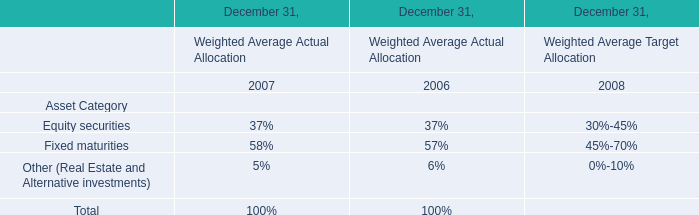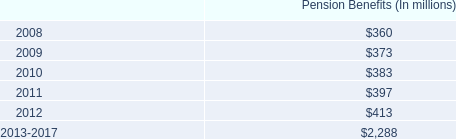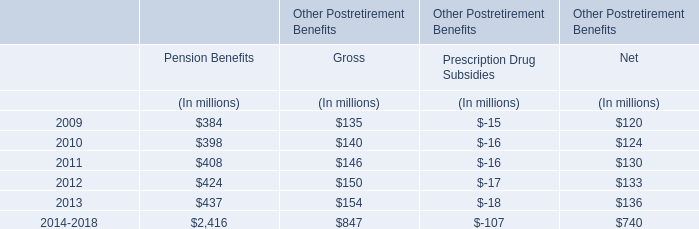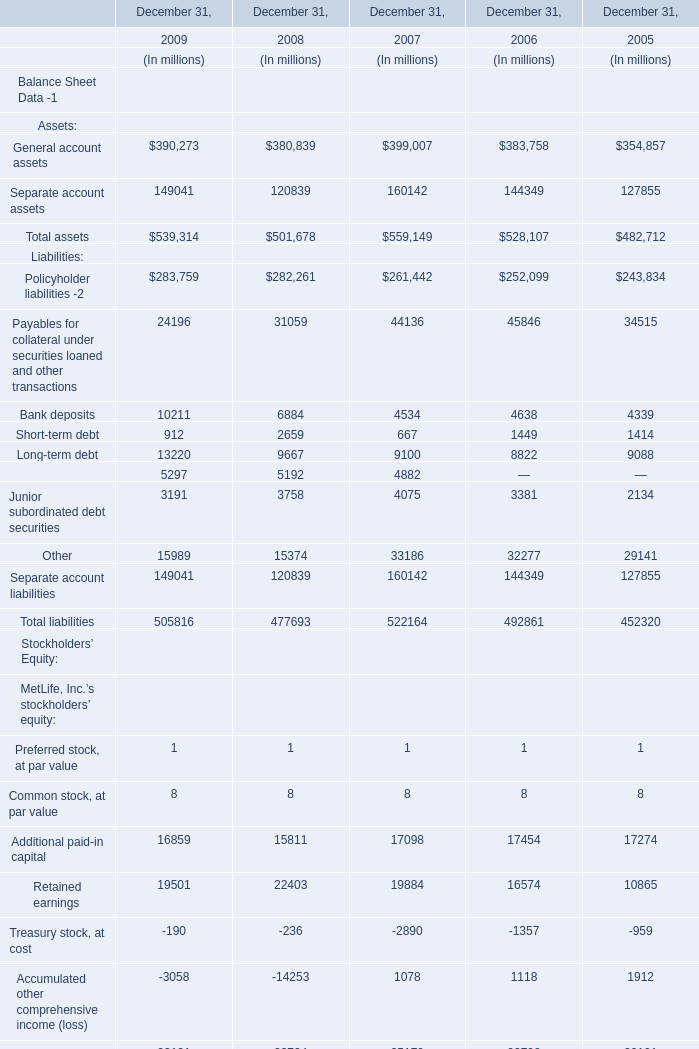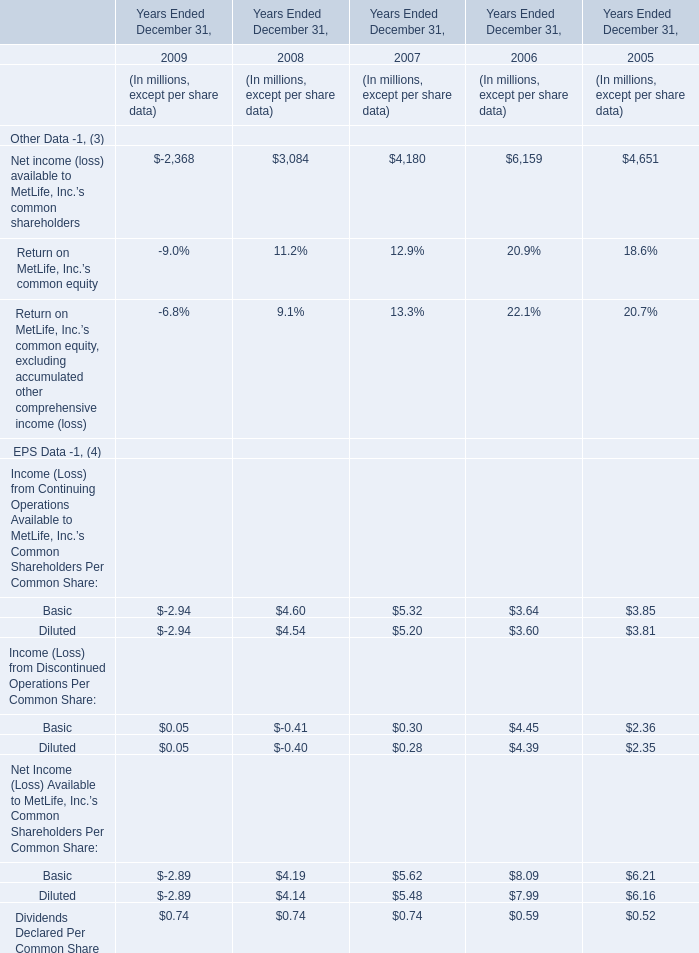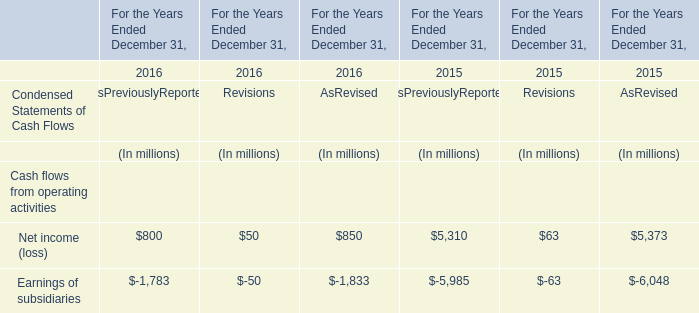What was the average of Other in 2009,2008, and 2007? (in million) 
Computations: (((15989 + 15374) + 33186) / 3)
Answer: 21516.33333. 